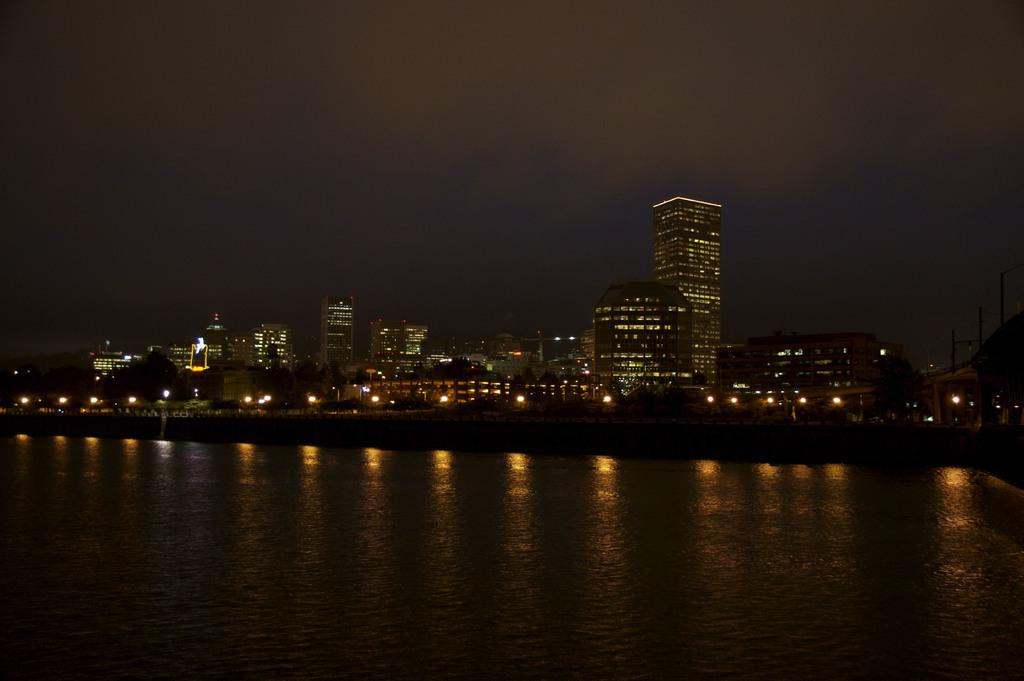What type of location is shown in the image? The image depicts a city. What natural element can be seen in the image? There is water visible in the image. What type of buildings are present in the city? Skyscrapers are present in the image. What is visible in the background of the image? The sky is visible in the background of the image. What base has been discovered in the image? There is no mention of a base or any discovery in the image. 